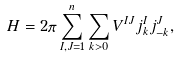<formula> <loc_0><loc_0><loc_500><loc_500>H = 2 \pi \sum _ { I , J = 1 } ^ { n } \sum _ { k > 0 } V ^ { I J } j _ { k } ^ { I } j _ { - k } ^ { J } ,</formula> 